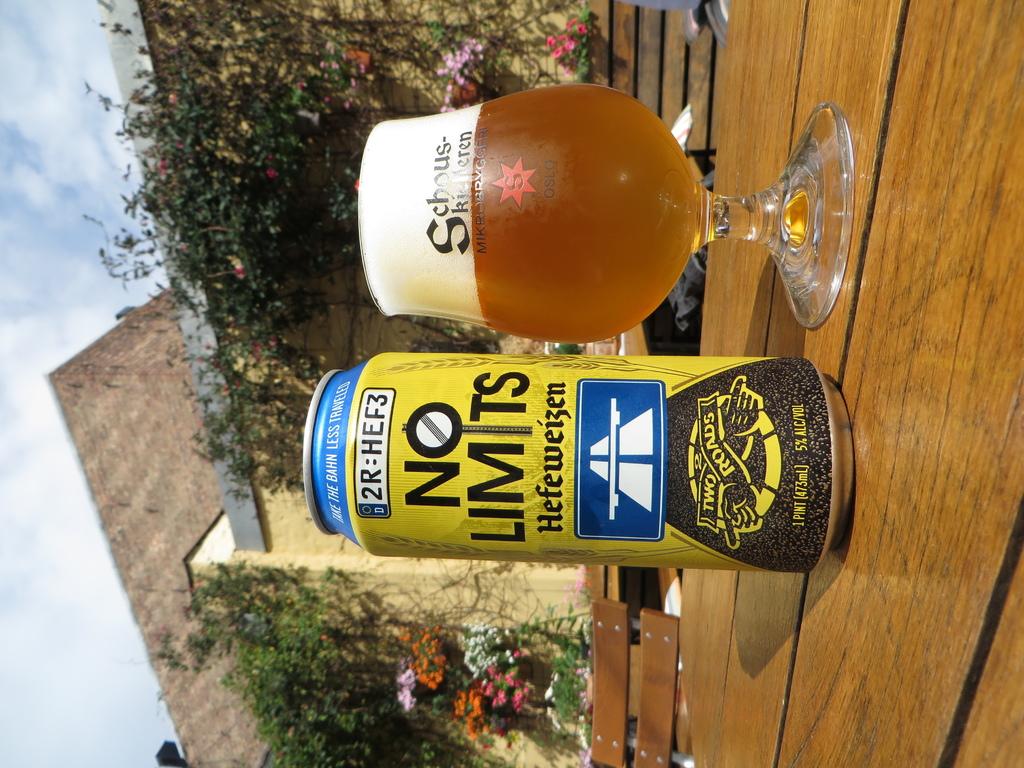What kind of beer is the yellow can?
Your answer should be very brief. No limits. How much alcohol by volume is this beer?
Offer a very short reply. 5%. 